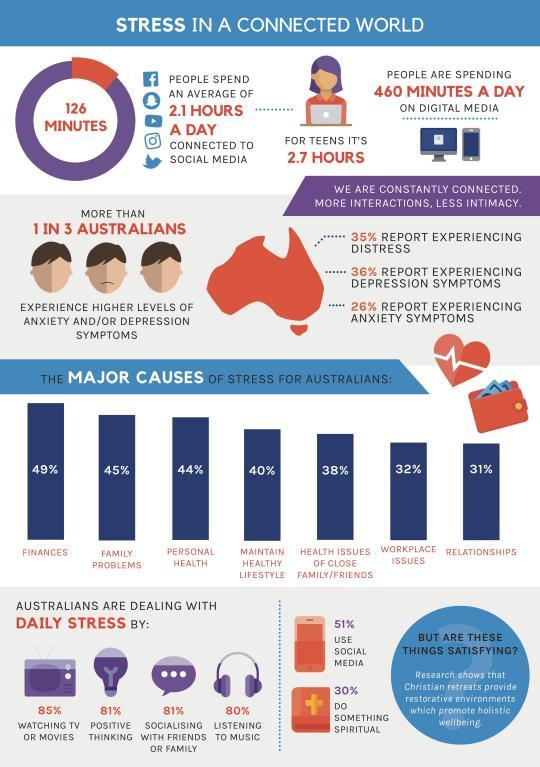What percentage of the Australians deal with stress by listening to music?
Answer the question with a short phrase. 80% What percentage of the Australians felt personal health as the major cause of stress? 44% What is the average minutes per day spend by the Australians in social media? 126 What percentage of the Australians deal with daily stress by positive thinking? 81% What percentage of the Australians do not use social media? 49% What is the major cause of stress in Australians? FINANCES What percentage of the Australians felt family problems as the major cause of stress? 45% What percentage of the Australians felt workplace issues as the major cause of stress? 32% What percentage of the Australians felt relationships as the major cause of stress? 31% 